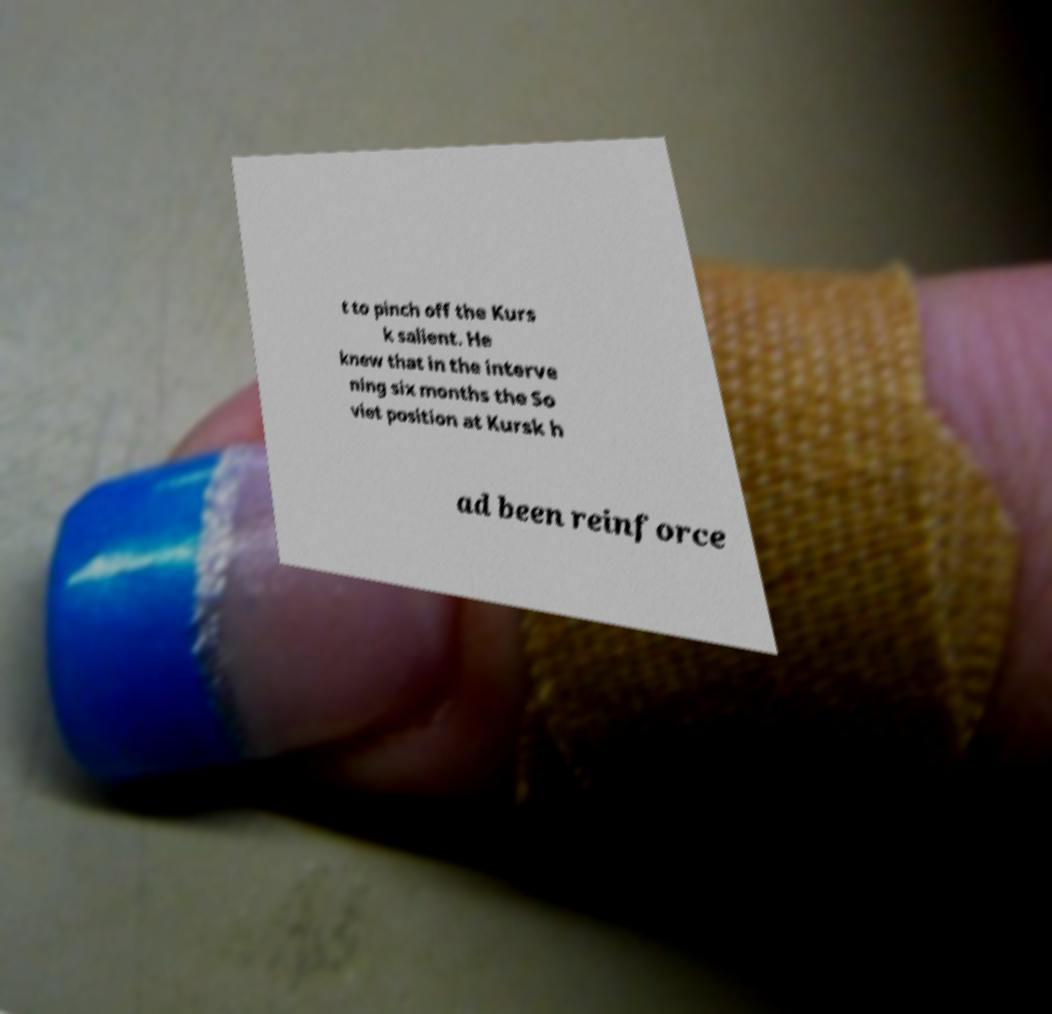For documentation purposes, I need the text within this image transcribed. Could you provide that? t to pinch off the Kurs k salient. He knew that in the interve ning six months the So viet position at Kursk h ad been reinforce 